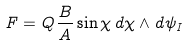<formula> <loc_0><loc_0><loc_500><loc_500>F = Q \frac { B } { A } \sin \chi \, d \chi \wedge d \psi _ { I }</formula> 